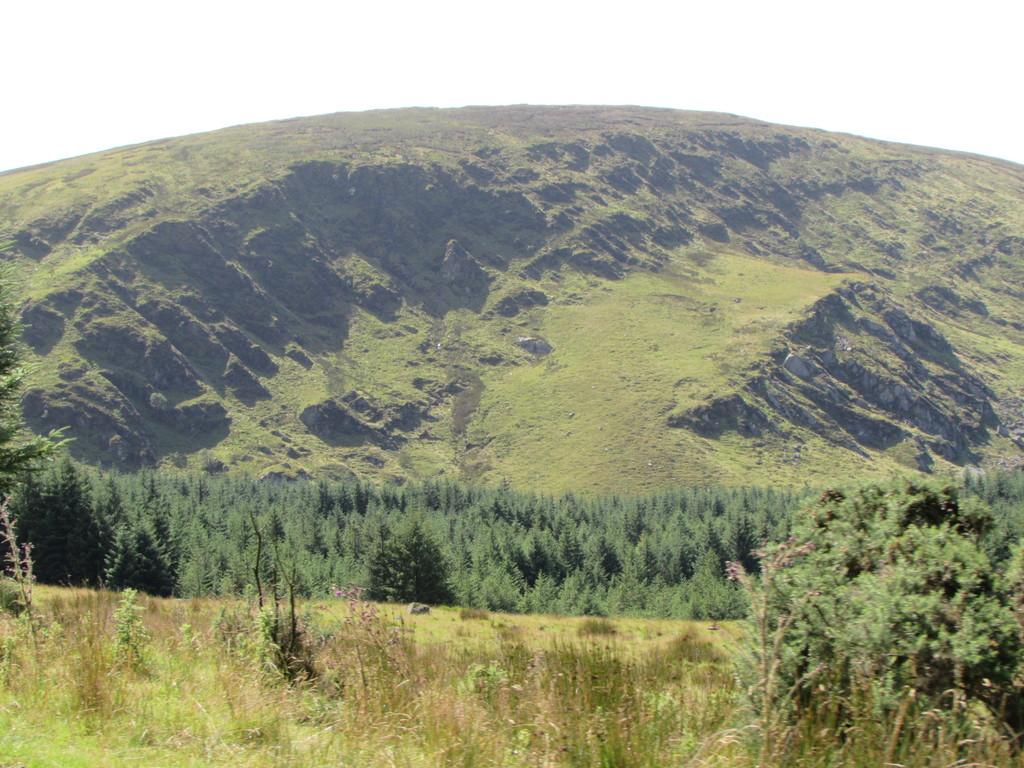What type of vegetation is present in the image? The image contains a lot of trees and grass. Can you describe the landscape in the image? The landscape is dominated by trees and grass, suggesting a natural setting. What type of road can be seen in the image? There is no road present in the image; it features a lot of trees and grass. What shape is the angle of the trees in the image? The image does not depict the shape of the angle of the trees; it simply shows trees and grass in a natural setting. 